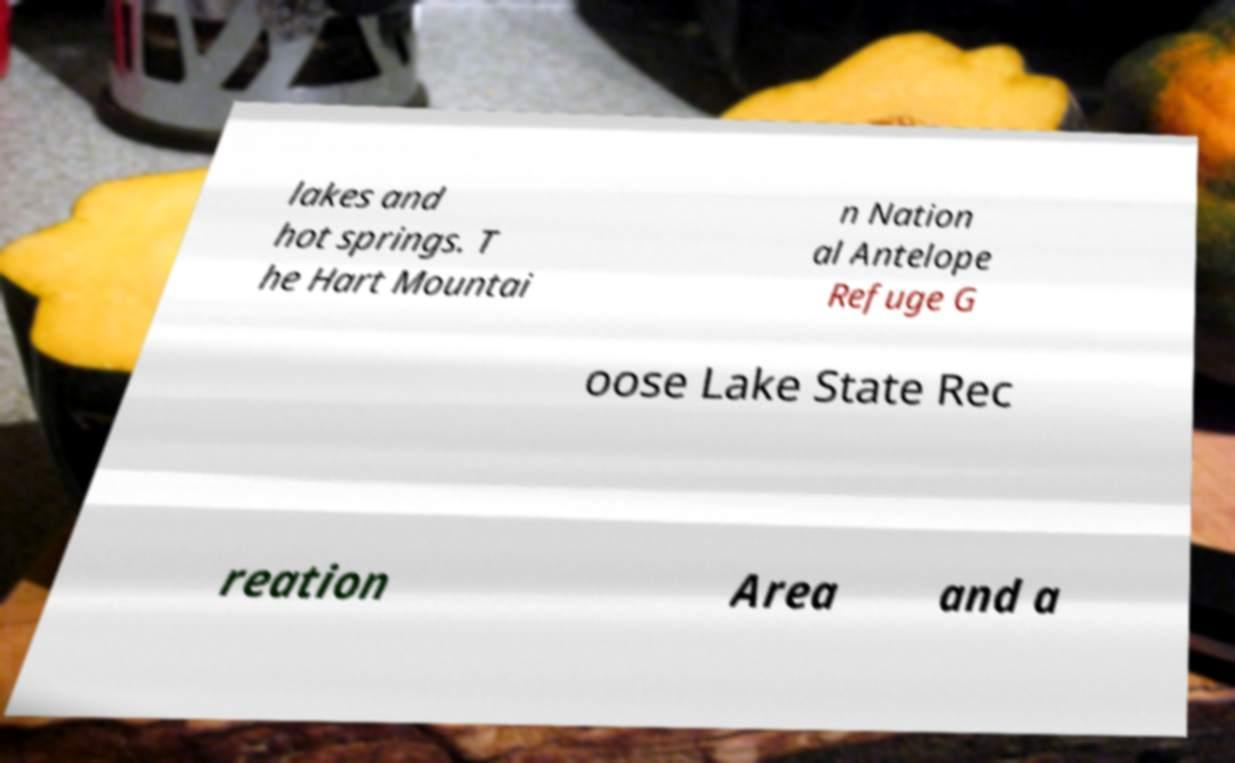For documentation purposes, I need the text within this image transcribed. Could you provide that? lakes and hot springs. T he Hart Mountai n Nation al Antelope Refuge G oose Lake State Rec reation Area and a 